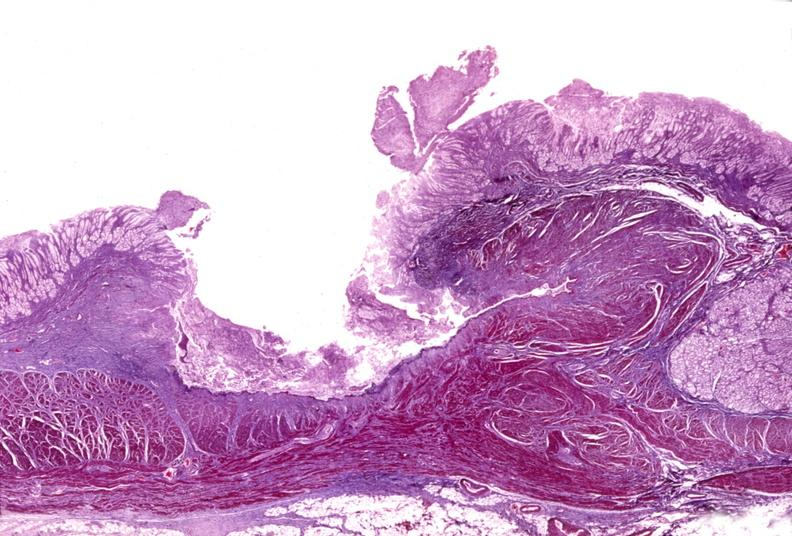does marked show stomach, subacute peptic ulcer?
Answer the question using a single word or phrase. No 